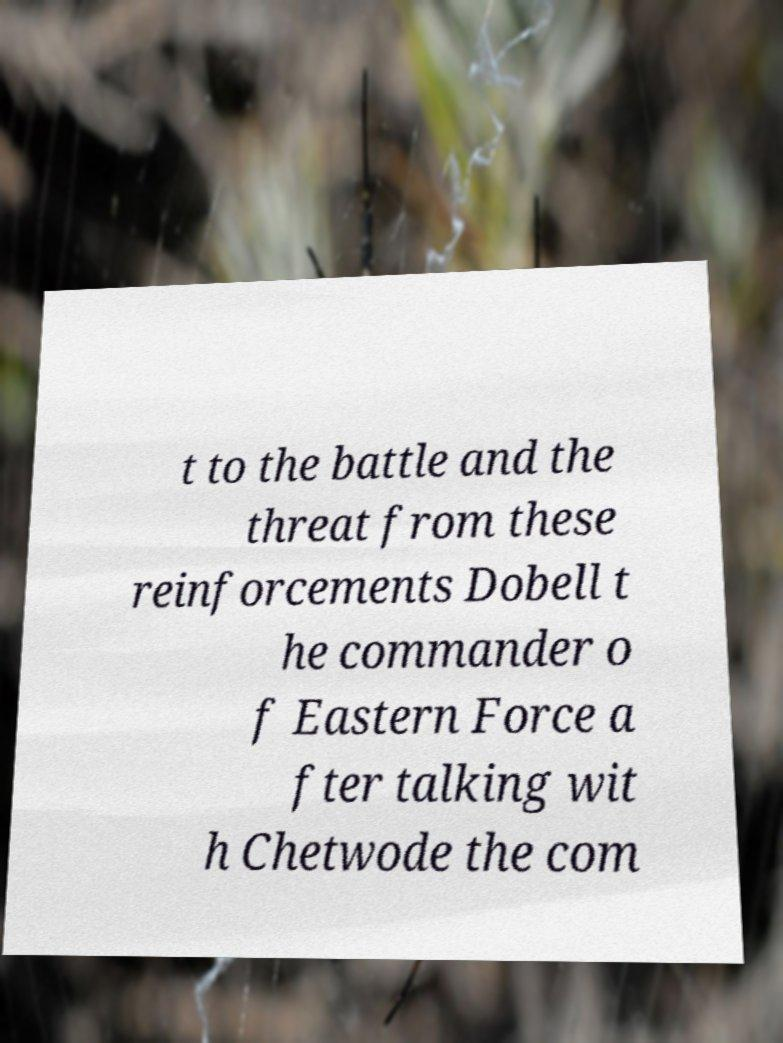Can you read and provide the text displayed in the image?This photo seems to have some interesting text. Can you extract and type it out for me? t to the battle and the threat from these reinforcements Dobell t he commander o f Eastern Force a fter talking wit h Chetwode the com 